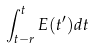<formula> <loc_0><loc_0><loc_500><loc_500>\int _ { t - r } ^ { t } E ( t ^ { \prime } ) d t</formula> 